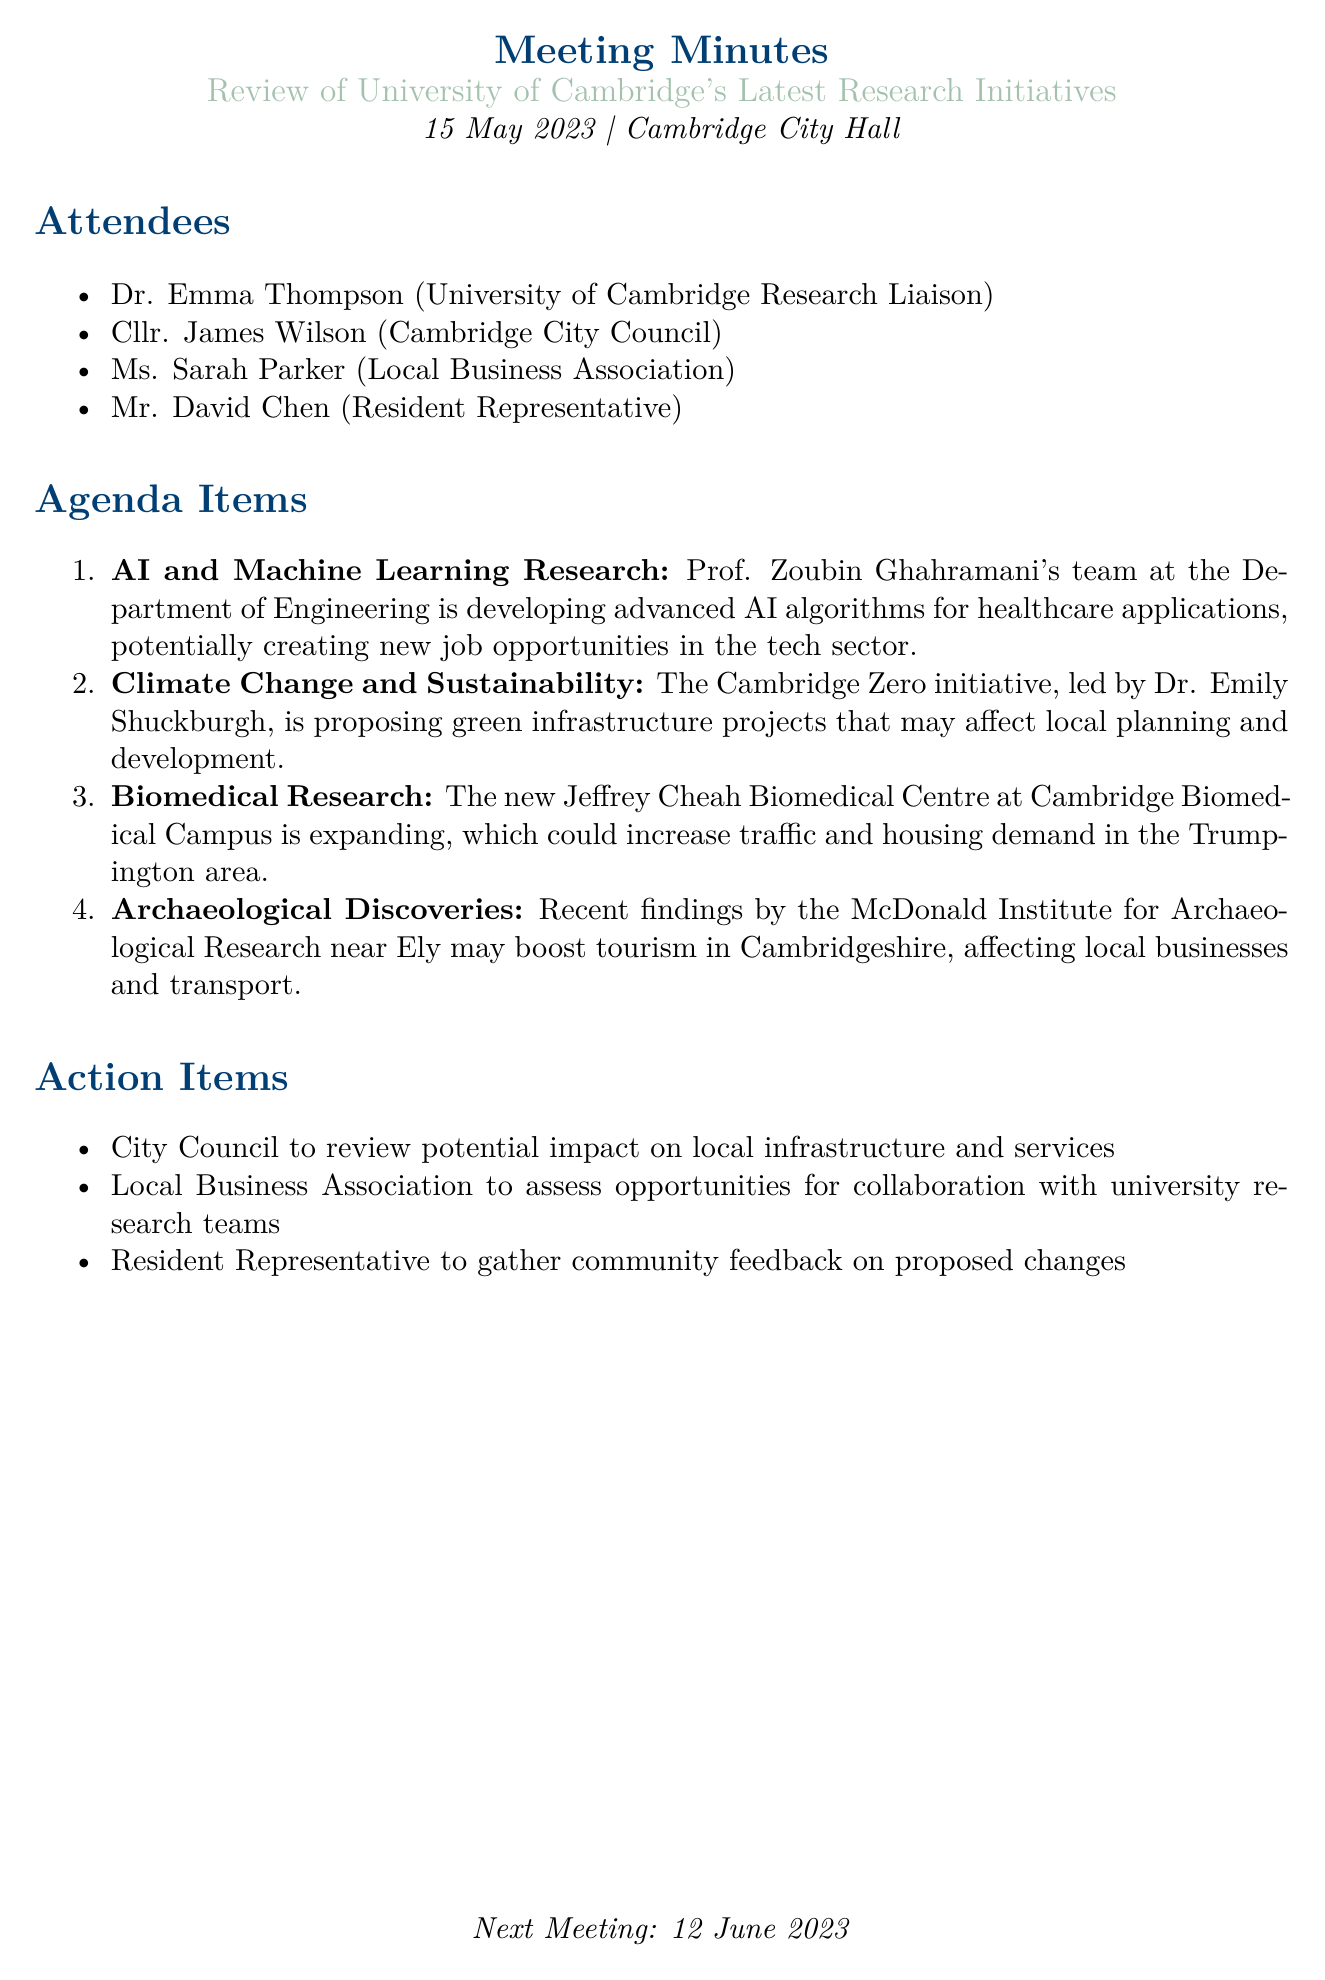What is the meeting date? The meeting date is explicitly mentioned in the document as May 15, 2023.
Answer: May 15, 2023 Who is leading the Cambridge Zero initiative? The document states that Dr. Emily Shuckburgh is leading the Cambridge Zero initiative.
Answer: Dr. Emily Shuckburgh What is the focus area of Prof. Zoubin Ghahramani's team? The document indicates that the focus area is the development of advanced AI algorithms for healthcare applications.
Answer: AI algorithms for healthcare applications Which area may experience increased traffic due to biomedical research expansion? The document specifies the Trumpington area as the location that might see increased traffic due to the expansion of the Jeffrey Cheah Biomedical Centre.
Answer: Trumpington What is listed as a potential benefit of archaeological discoveries near Ely? According to the document, the potential benefit is a boost in tourism in Cambridgeshire, which could positively affect local businesses and transport.
Answer: Boost tourism What is one of the action items for the City Council? The document outlines that the City Council should review the potential impact on local infrastructure and services.
Answer: Review potential impact on local infrastructure and services When is the next meeting scheduled? The document explicitly states the next meeting date as June 12, 2023.
Answer: June 12, 2023 Who represents the local business interests in the meeting? The document lists Ms. Sarah Parker as the representative of the Local Business Association.
Answer: Ms. Sarah Parker 